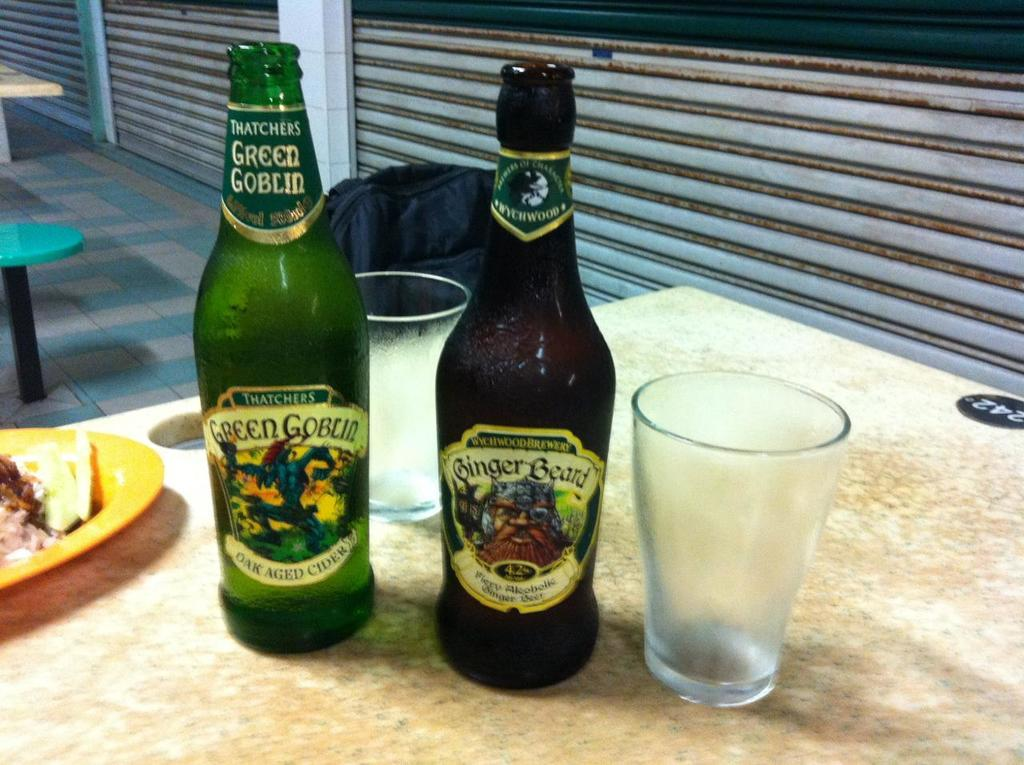<image>
Write a terse but informative summary of the picture. a bottle of thatchers green goblin aok aged cider in a green water 